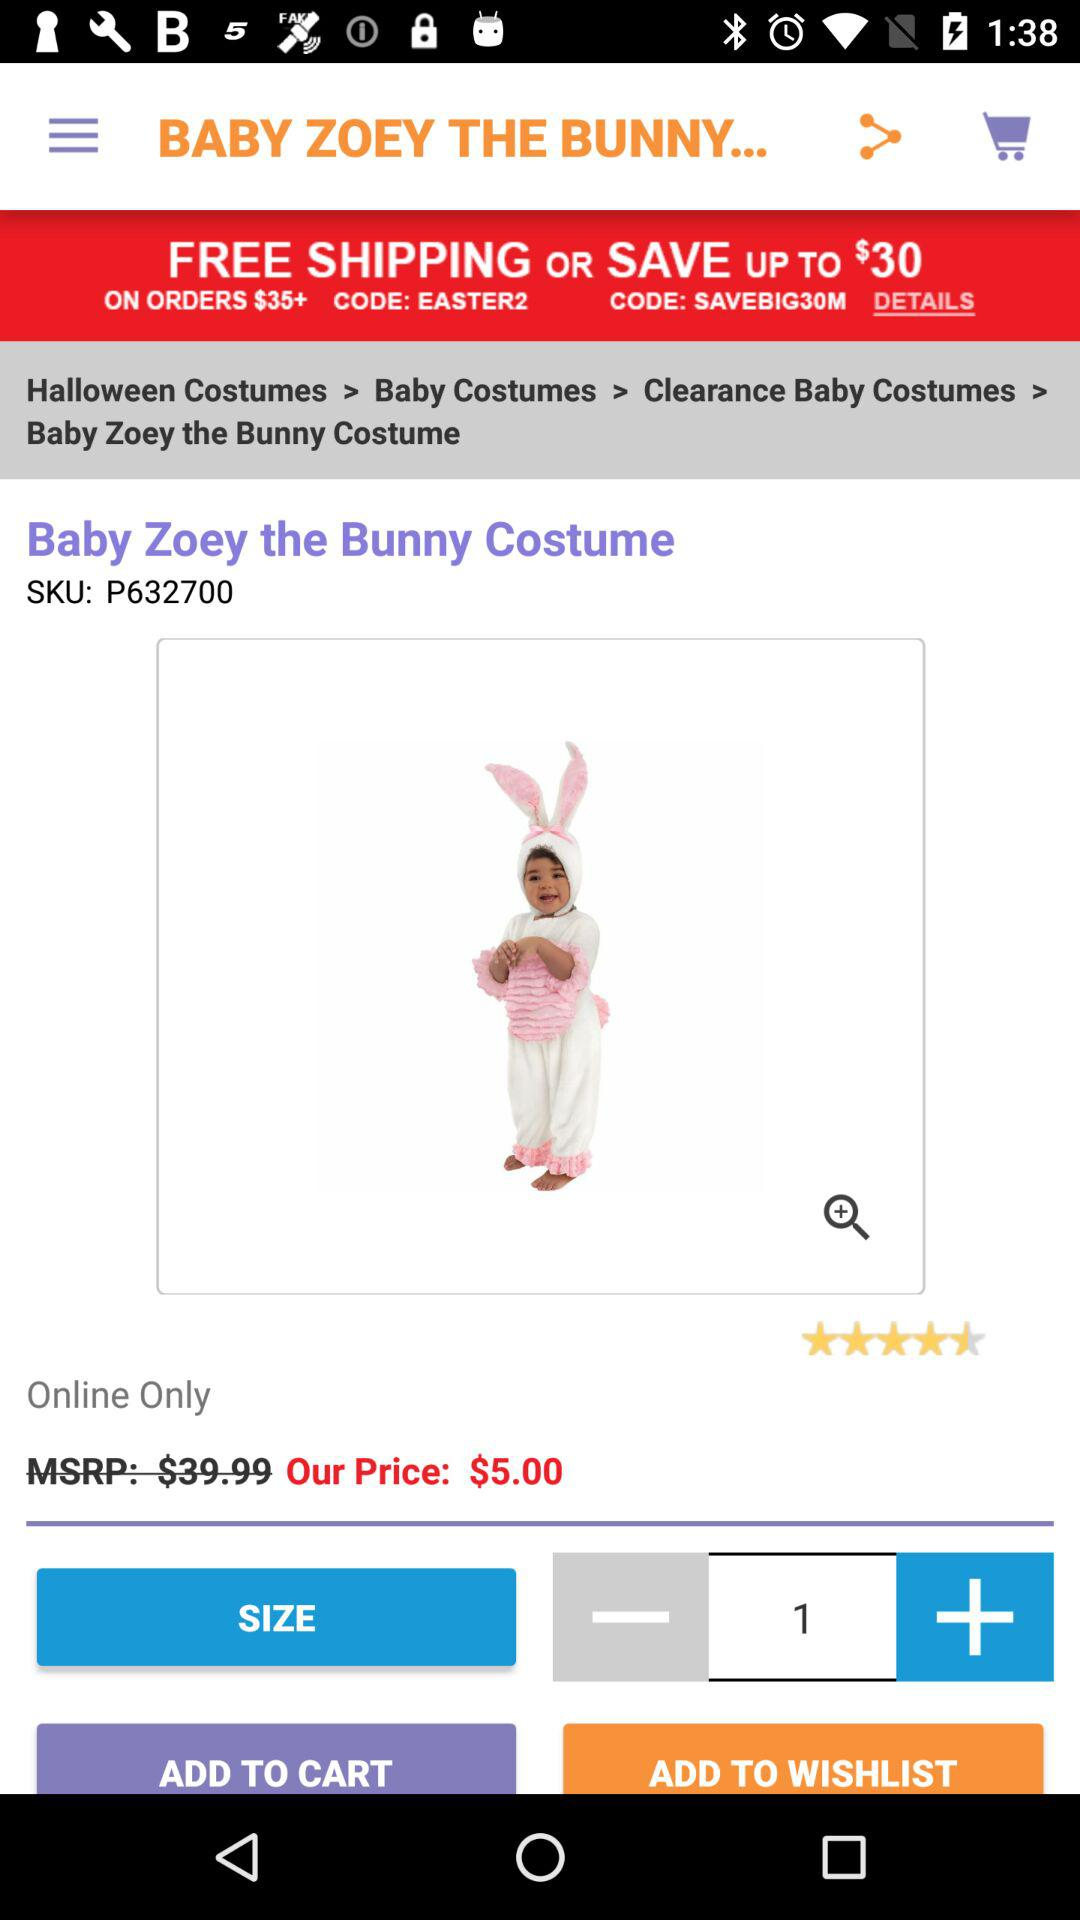What is the application name?
When the provided information is insufficient, respond with <no answer>. <no answer> 